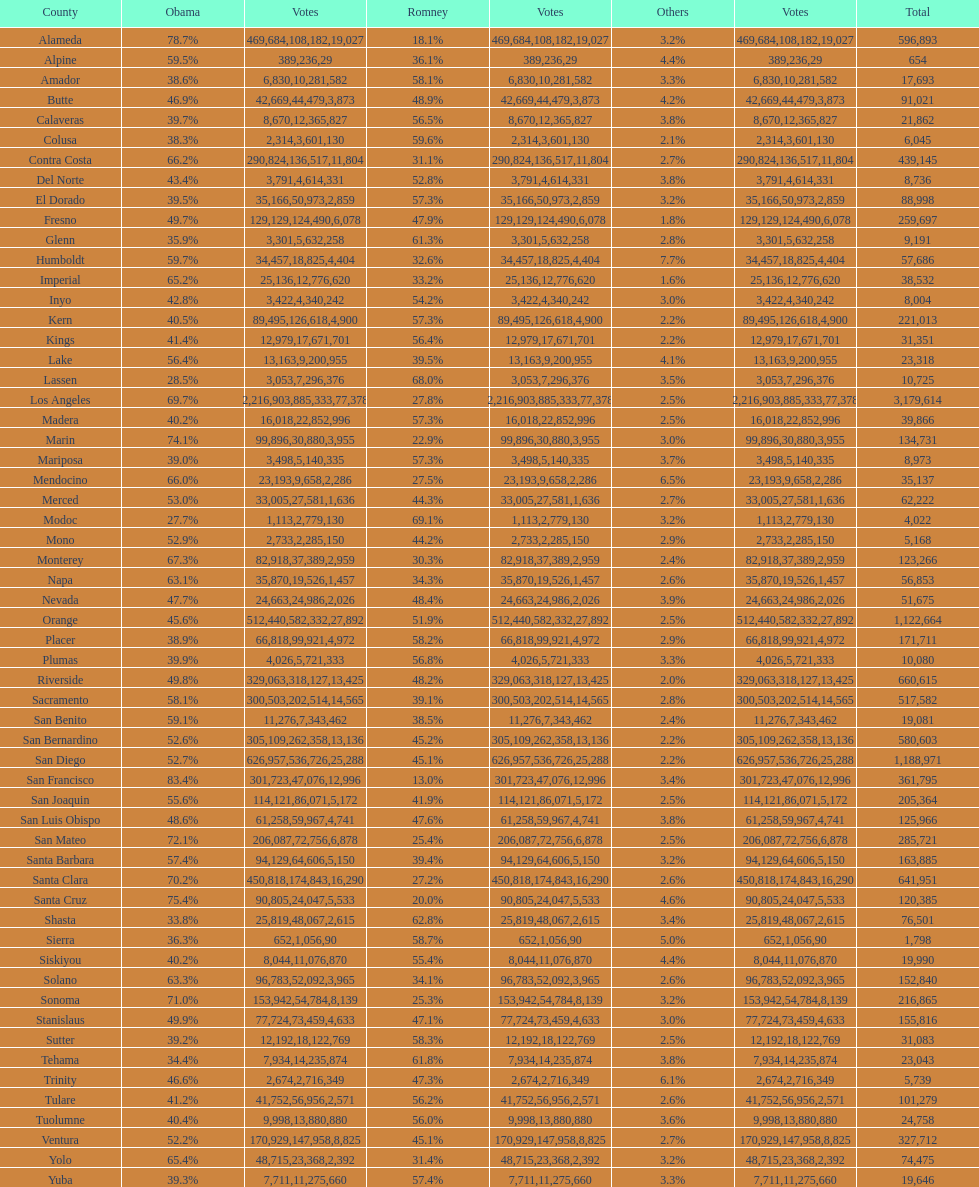In which county were the highest number of total votes recorded? Los Angeles. 